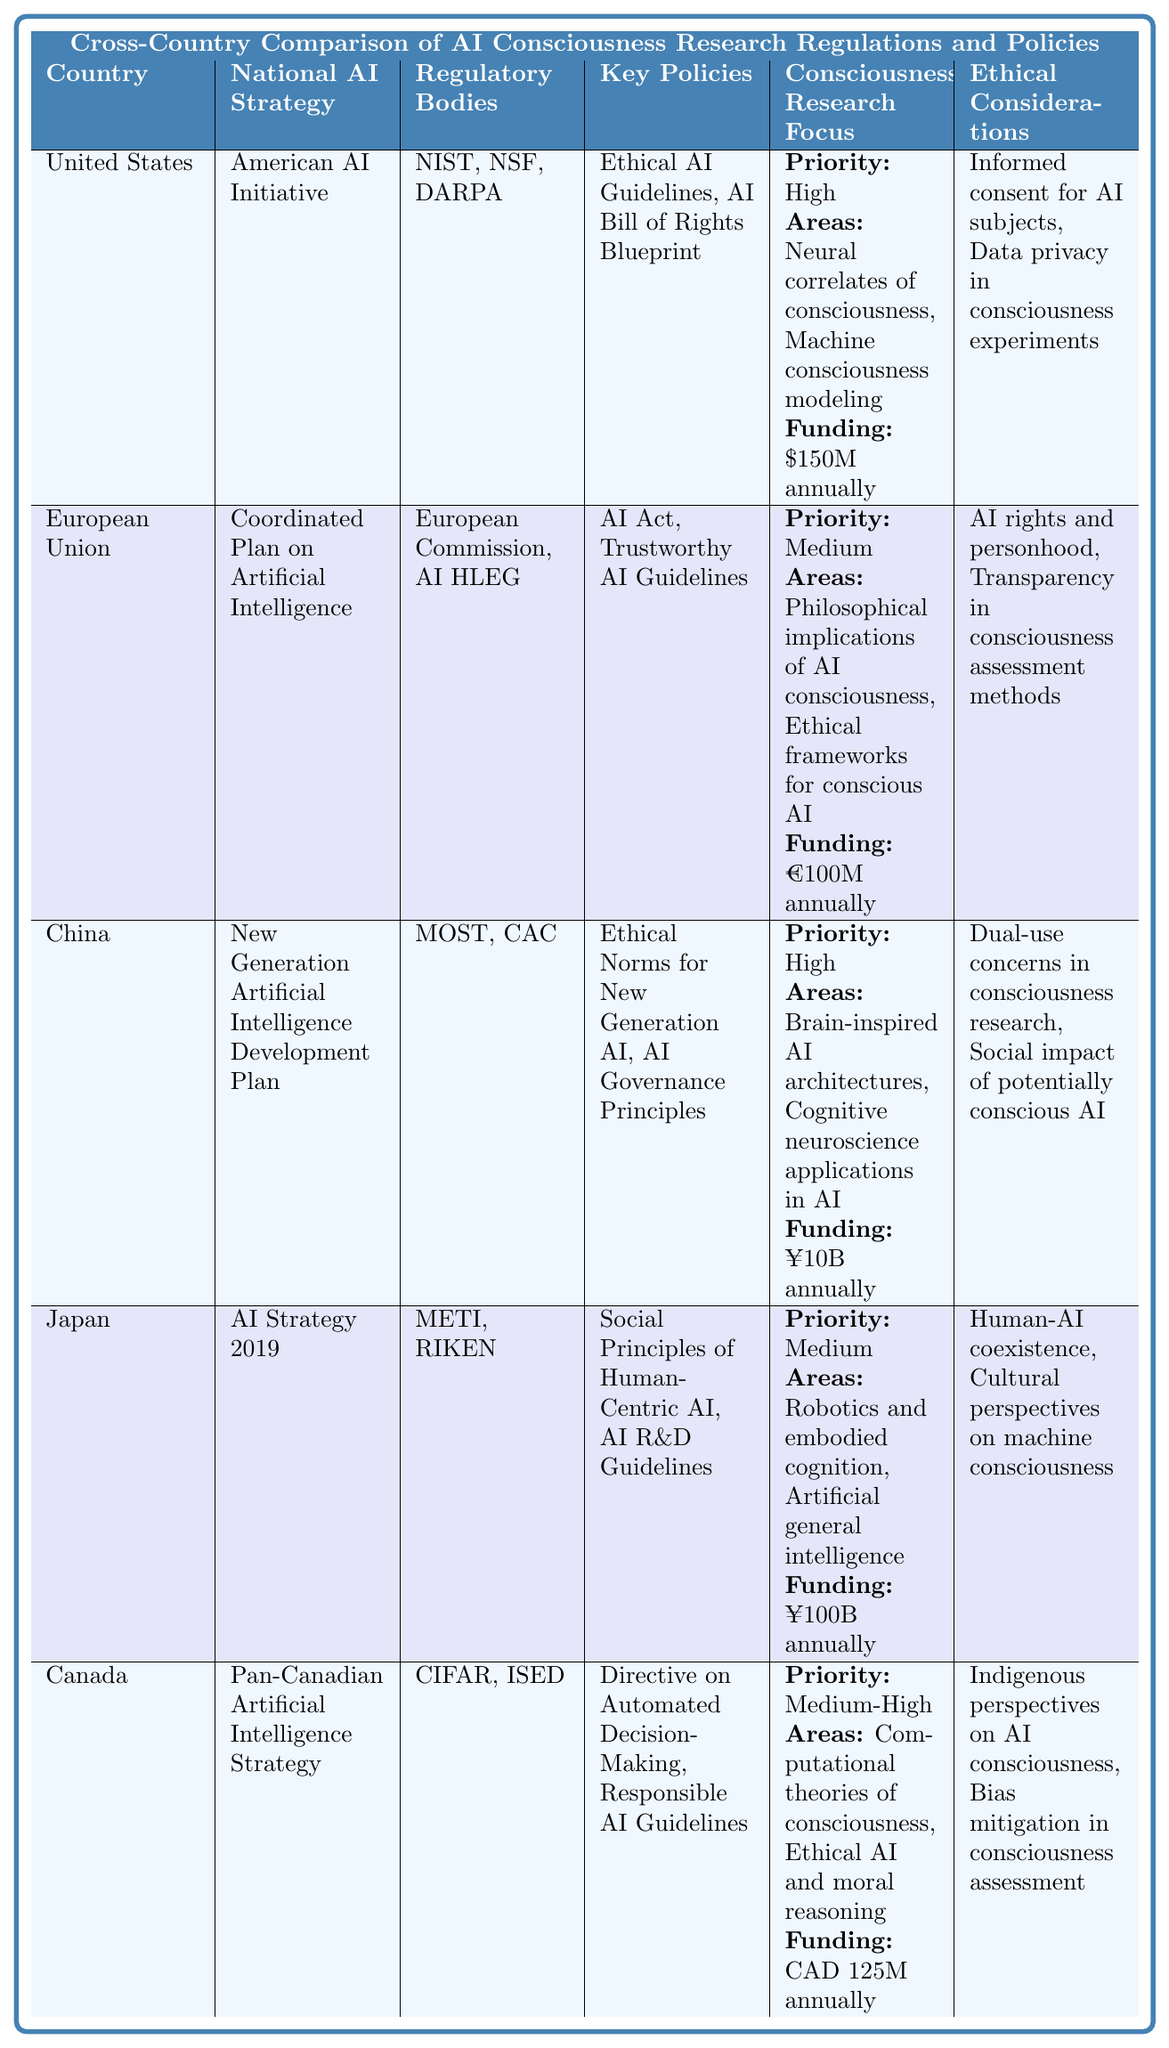What is the national AI strategy of China? According to the table, China’s national AI strategy is listed as the "New Generation Artificial Intelligence Development Plan."
Answer: New Generation Artificial Intelligence Development Plan Which country allocates the highest funding for consciousness research? The table shows that the United States allocates $150 million annually, while China allocates ¥10 billion, which is roughly equivalent to $1.5 billion based on current currency conversion rates. Thus, the United States has the highest funding allocation.
Answer: United States Does Japan prioritize consciousness research at a high level? In the table, Japan's consciousness research focus is marked as a "Medium" priority level, which indicates it does not fall under a high priority.
Answer: No How much funding does the European Union allocate annually for consciousness research? The funding allocation for consciousness research in the European Union, as specified in the table, is €100 million annually.
Answer: €100 million Which regulatory bodies are involved in consciousness research in Canada? The table indicates that in Canada, the regulatory bodies involved are CIFAR and ISED.
Answer: CIFAR, ISED If you compare the priority levels for consciousness research between the United States and Canada, which country has a higher priority? The United States is categorized under "High" priority for consciousness research, while Canada is at "Medium-High." Therefore, the United States has a higher priority level.
Answer: United States Is the ethical consideration of AI rights and personhood included in the regulations of the European Union? Yes, the table lists "AI rights and personhood" as one of the ethical considerations for the European Union, confirming that it is included in their regulations.
Answer: Yes What are the key areas of consciousness research focus for Canada? The table lists Canada’s key areas of consciousness research focus as "Computational theories of consciousness" and "Ethical AI and moral reasoning."
Answer: Computational theories of consciousness, Ethical AI and moral reasoning Which country has a focus on "robotics and embodied cognition" in its consciousness research, and what is its funding allocation? Japan has a focus on "robotics and embodied cognition." The funding allocation for Japan is ¥100 billion annually.
Answer: Japan; ¥100 billion Calculate the total funding allocation for consciousness research when adding the amounts from the United States and Canada. The United States allocates $150 million and Canada allocates CAD 125 million. The total allocation is $150 million + $125 million (assuming CAD does not convert for this summation) = $275 million.
Answer: $275 million Which country has the most complex ethical considerations according to the table, and what are they? By examining the ethical considerations, China’s dual-use concerns and social impact of potentially conscious AI suggest a more complex approach.
Answer: China; dual-use concerns, social impact of potentially conscious AI 